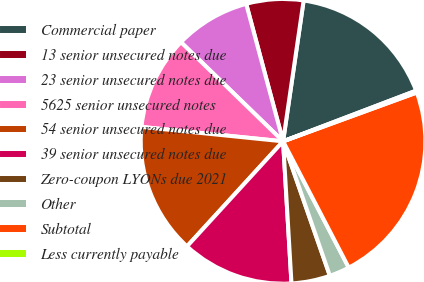<chart> <loc_0><loc_0><loc_500><loc_500><pie_chart><fcel>Commercial paper<fcel>13 senior unsecured notes due<fcel>23 senior unsecured notes due<fcel>5625 senior unsecured notes<fcel>54 senior unsecured notes due<fcel>39 senior unsecured notes due<fcel>Zero-coupon LYONs due 2021<fcel>Other<fcel>Subtotal<fcel>Less currently payable<nl><fcel>16.9%<fcel>6.48%<fcel>8.56%<fcel>10.65%<fcel>14.82%<fcel>12.73%<fcel>4.39%<fcel>2.3%<fcel>22.94%<fcel>0.22%<nl></chart> 